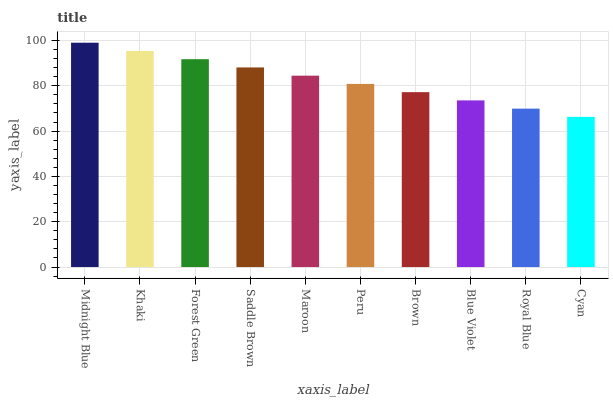Is Khaki the minimum?
Answer yes or no. No. Is Khaki the maximum?
Answer yes or no. No. Is Midnight Blue greater than Khaki?
Answer yes or no. Yes. Is Khaki less than Midnight Blue?
Answer yes or no. Yes. Is Khaki greater than Midnight Blue?
Answer yes or no. No. Is Midnight Blue less than Khaki?
Answer yes or no. No. Is Maroon the high median?
Answer yes or no. Yes. Is Peru the low median?
Answer yes or no. Yes. Is Royal Blue the high median?
Answer yes or no. No. Is Blue Violet the low median?
Answer yes or no. No. 